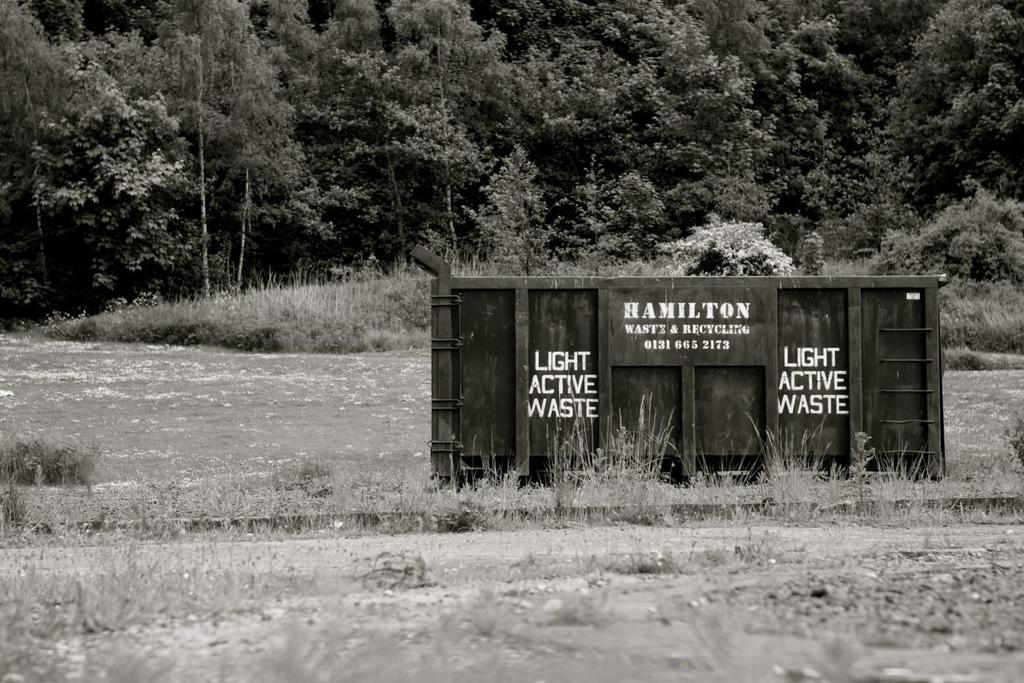What is the main object in the image? There is a board in the image. What is on the board? There is writing on the board. What can be seen in the background of the image? The background of the image includes trees. What is the color scheme of the image? The image is in black and white. Are there any dinosaurs visible in the image? No, there are no dinosaurs present in the image. How does the digestion process of the trees in the background appear in the image? The image does not depict the digestion process of the trees; it only shows the trees in the background. 